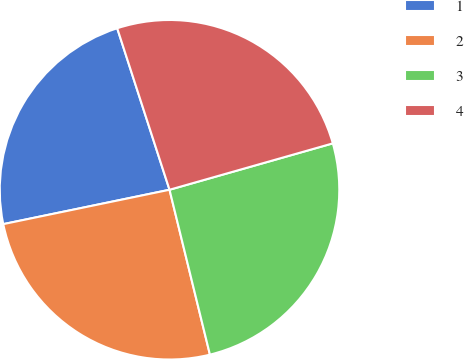<chart> <loc_0><loc_0><loc_500><loc_500><pie_chart><fcel>1<fcel>2<fcel>3<fcel>4<nl><fcel>23.26%<fcel>25.58%<fcel>25.58%<fcel>25.58%<nl></chart> 